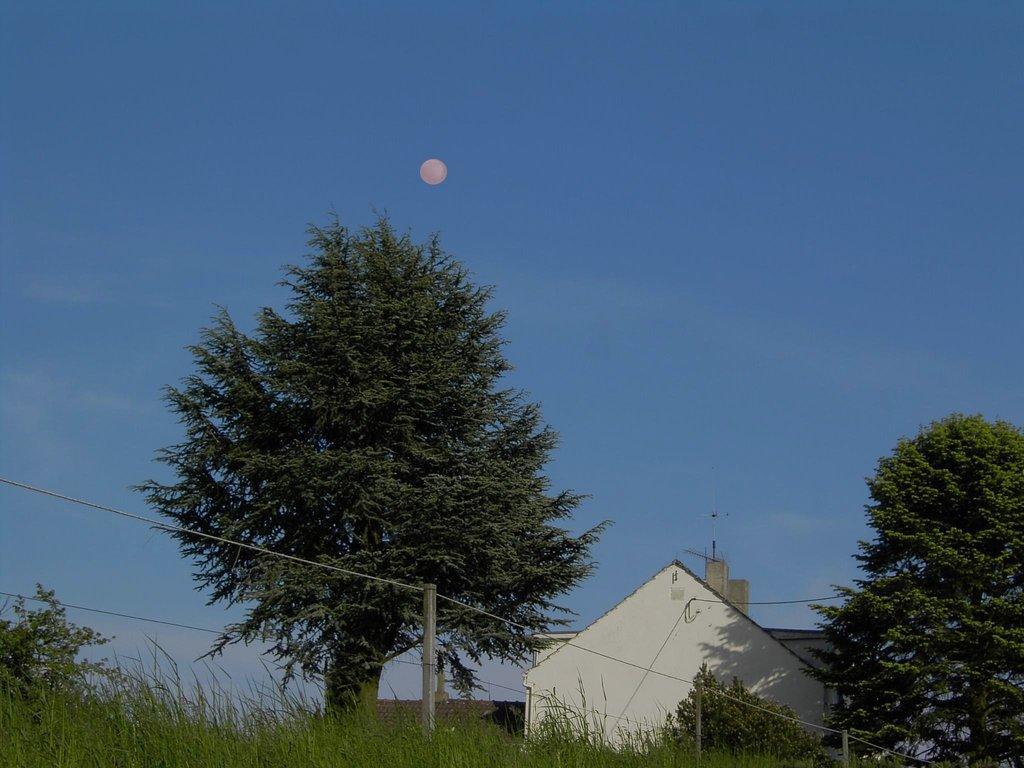Could you give a brief overview of what you see in this image? In the foreground I can see grass, plants, fence, trees, houses. In the background I can see the sky and the sun. This image is taken may be during a day. 